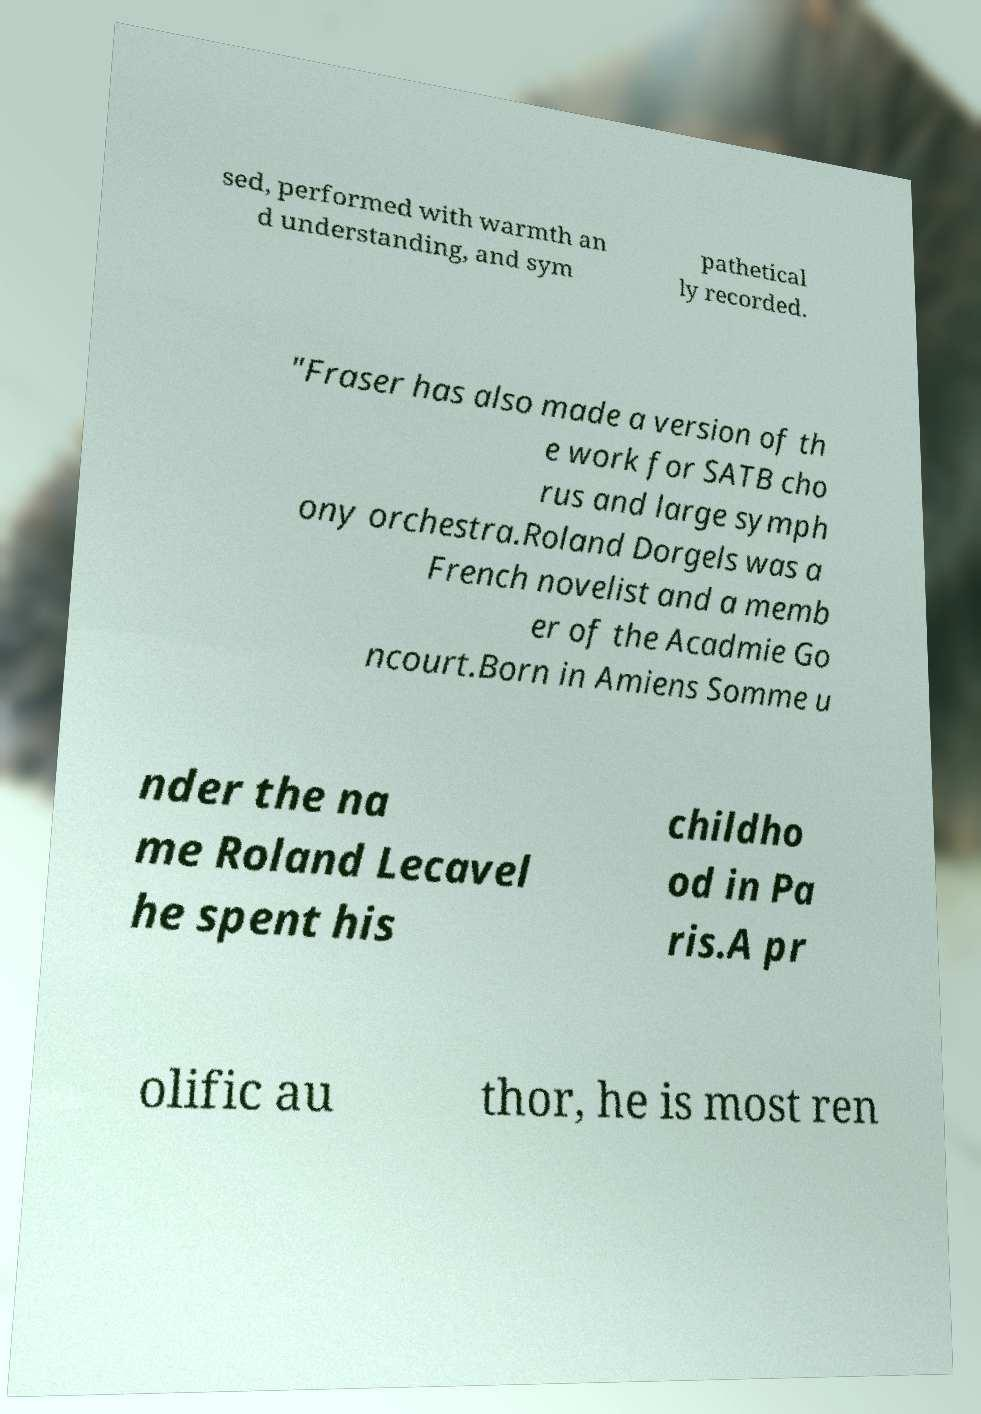Can you accurately transcribe the text from the provided image for me? sed, performed with warmth an d understanding, and sym pathetical ly recorded. "Fraser has also made a version of th e work for SATB cho rus and large symph ony orchestra.Roland Dorgels was a French novelist and a memb er of the Acadmie Go ncourt.Born in Amiens Somme u nder the na me Roland Lecavel he spent his childho od in Pa ris.A pr olific au thor, he is most ren 